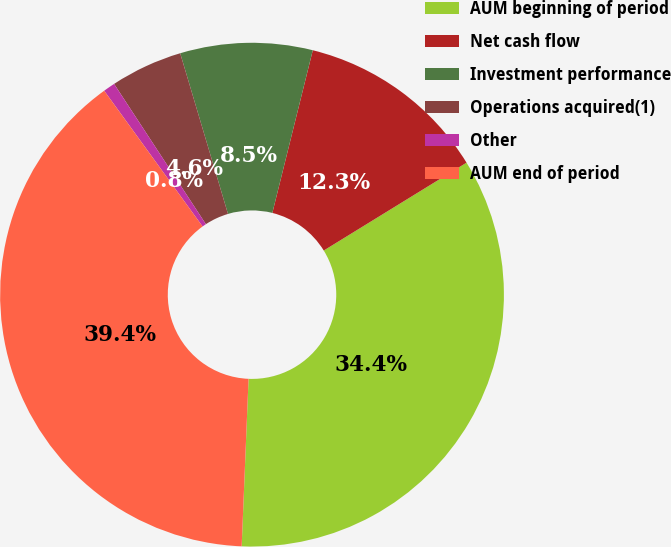Convert chart to OTSL. <chart><loc_0><loc_0><loc_500><loc_500><pie_chart><fcel>AUM beginning of period<fcel>Net cash flow<fcel>Investment performance<fcel>Operations acquired(1)<fcel>Other<fcel>AUM end of period<nl><fcel>34.43%<fcel>12.34%<fcel>8.48%<fcel>4.62%<fcel>0.76%<fcel>39.36%<nl></chart> 